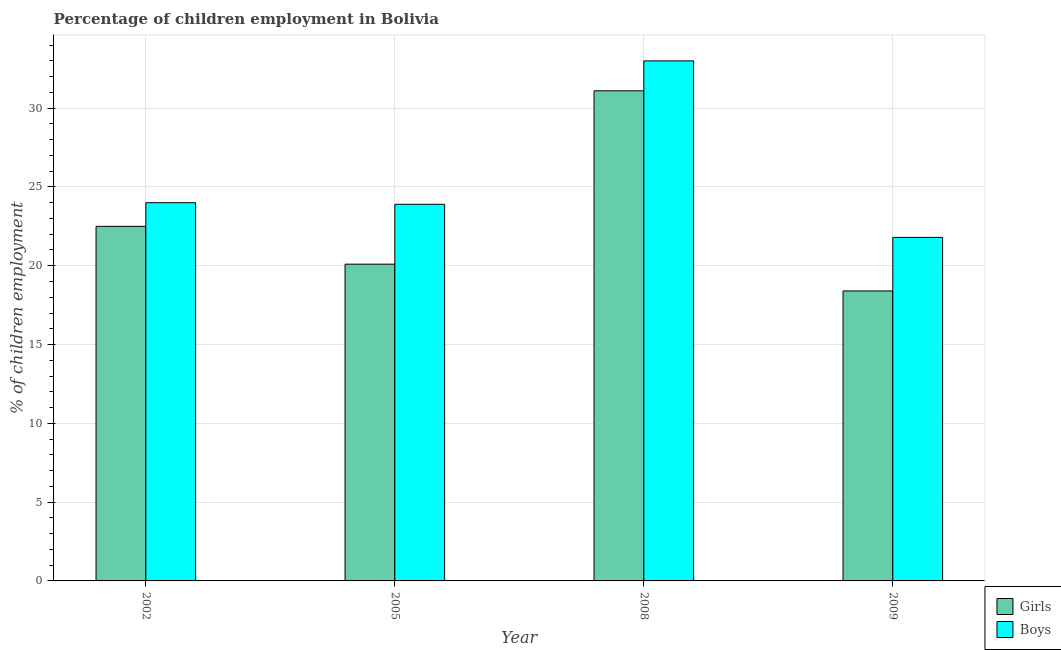Are the number of bars on each tick of the X-axis equal?
Offer a very short reply. Yes. In how many cases, is the number of bars for a given year not equal to the number of legend labels?
Ensure brevity in your answer.  0. Across all years, what is the maximum percentage of employed girls?
Make the answer very short. 31.1. In which year was the percentage of employed boys maximum?
Give a very brief answer. 2008. In which year was the percentage of employed boys minimum?
Your answer should be very brief. 2009. What is the total percentage of employed boys in the graph?
Give a very brief answer. 102.7. What is the difference between the percentage of employed boys in 2005 and that in 2009?
Provide a short and direct response. 2.1. What is the difference between the percentage of employed boys in 2005 and the percentage of employed girls in 2008?
Your response must be concise. -9.1. What is the average percentage of employed boys per year?
Offer a terse response. 25.68. What is the ratio of the percentage of employed boys in 2002 to that in 2008?
Your response must be concise. 0.73. What is the difference between the highest and the second highest percentage of employed girls?
Your response must be concise. 8.6. What is the difference between the highest and the lowest percentage of employed girls?
Provide a short and direct response. 12.7. In how many years, is the percentage of employed girls greater than the average percentage of employed girls taken over all years?
Ensure brevity in your answer.  1. Is the sum of the percentage of employed boys in 2002 and 2005 greater than the maximum percentage of employed girls across all years?
Give a very brief answer. Yes. What does the 2nd bar from the left in 2008 represents?
Keep it short and to the point. Boys. What does the 2nd bar from the right in 2009 represents?
Provide a short and direct response. Girls. Are all the bars in the graph horizontal?
Keep it short and to the point. No. How many years are there in the graph?
Make the answer very short. 4. Does the graph contain any zero values?
Your answer should be compact. No. How many legend labels are there?
Give a very brief answer. 2. What is the title of the graph?
Give a very brief answer. Percentage of children employment in Bolivia. Does "From World Bank" appear as one of the legend labels in the graph?
Provide a succinct answer. No. What is the label or title of the Y-axis?
Give a very brief answer. % of children employment. What is the % of children employment of Girls in 2002?
Offer a terse response. 22.5. What is the % of children employment in Boys in 2002?
Your answer should be compact. 24. What is the % of children employment of Girls in 2005?
Offer a very short reply. 20.1. What is the % of children employment of Boys in 2005?
Your answer should be compact. 23.9. What is the % of children employment of Girls in 2008?
Offer a very short reply. 31.1. What is the % of children employment in Girls in 2009?
Offer a very short reply. 18.4. What is the % of children employment of Boys in 2009?
Provide a short and direct response. 21.8. Across all years, what is the maximum % of children employment in Girls?
Provide a succinct answer. 31.1. Across all years, what is the maximum % of children employment of Boys?
Make the answer very short. 33. Across all years, what is the minimum % of children employment in Boys?
Provide a short and direct response. 21.8. What is the total % of children employment of Girls in the graph?
Ensure brevity in your answer.  92.1. What is the total % of children employment of Boys in the graph?
Make the answer very short. 102.7. What is the difference between the % of children employment of Girls in 2002 and that in 2005?
Give a very brief answer. 2.4. What is the difference between the % of children employment in Boys in 2002 and that in 2008?
Offer a very short reply. -9. What is the difference between the % of children employment of Boys in 2002 and that in 2009?
Provide a succinct answer. 2.2. What is the difference between the % of children employment of Girls in 2005 and that in 2008?
Make the answer very short. -11. What is the difference between the % of children employment of Boys in 2005 and that in 2009?
Offer a terse response. 2.1. What is the difference between the % of children employment in Girls in 2002 and the % of children employment in Boys in 2008?
Offer a very short reply. -10.5. What is the difference between the % of children employment of Girls in 2005 and the % of children employment of Boys in 2008?
Provide a succinct answer. -12.9. What is the difference between the % of children employment of Girls in 2008 and the % of children employment of Boys in 2009?
Provide a succinct answer. 9.3. What is the average % of children employment of Girls per year?
Keep it short and to the point. 23.02. What is the average % of children employment in Boys per year?
Provide a succinct answer. 25.68. In the year 2002, what is the difference between the % of children employment in Girls and % of children employment in Boys?
Ensure brevity in your answer.  -1.5. What is the ratio of the % of children employment in Girls in 2002 to that in 2005?
Your answer should be compact. 1.12. What is the ratio of the % of children employment in Girls in 2002 to that in 2008?
Offer a very short reply. 0.72. What is the ratio of the % of children employment in Boys in 2002 to that in 2008?
Your answer should be compact. 0.73. What is the ratio of the % of children employment in Girls in 2002 to that in 2009?
Your response must be concise. 1.22. What is the ratio of the % of children employment of Boys in 2002 to that in 2009?
Provide a short and direct response. 1.1. What is the ratio of the % of children employment of Girls in 2005 to that in 2008?
Your response must be concise. 0.65. What is the ratio of the % of children employment of Boys in 2005 to that in 2008?
Your answer should be compact. 0.72. What is the ratio of the % of children employment in Girls in 2005 to that in 2009?
Make the answer very short. 1.09. What is the ratio of the % of children employment in Boys in 2005 to that in 2009?
Ensure brevity in your answer.  1.1. What is the ratio of the % of children employment in Girls in 2008 to that in 2009?
Offer a terse response. 1.69. What is the ratio of the % of children employment of Boys in 2008 to that in 2009?
Your response must be concise. 1.51. What is the difference between the highest and the second highest % of children employment of Girls?
Your response must be concise. 8.6. What is the difference between the highest and the second highest % of children employment of Boys?
Keep it short and to the point. 9. 